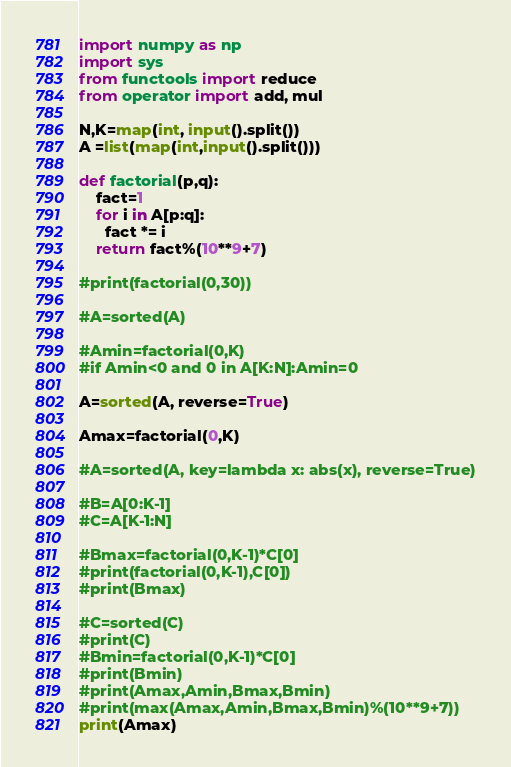<code> <loc_0><loc_0><loc_500><loc_500><_Python_>import numpy as np
import sys
from functools import reduce
from operator import add, mul
 
N,K=map(int, input().split())
A =list(map(int,input().split()))

def factorial(p,q):
    fact=1
    for i in A[p:q]:
      fact *= i
    return fact%(10**9+7)

#print(factorial(0,30))
      
#A=sorted(A)
 
#Amin=factorial(0,K)
#if Amin<0 and 0 in A[K:N]:Amin=0

A=sorted(A, reverse=True)
 
Amax=factorial(0,K)
 
#A=sorted(A, key=lambda x: abs(x), reverse=True)
 
#B=A[0:K-1]
#C=A[K-1:N]
 
#Bmax=factorial(0,K-1)*C[0]
#print(factorial(0,K-1),C[0])
#print(Bmax)
 
#C=sorted(C)
#print(C)
#Bmin=factorial(0,K-1)*C[0]
#print(Bmin)
#print(Amax,Amin,Bmax,Bmin)
#print(max(Amax,Amin,Bmax,Bmin)%(10**9+7))
print(Amax)</code> 